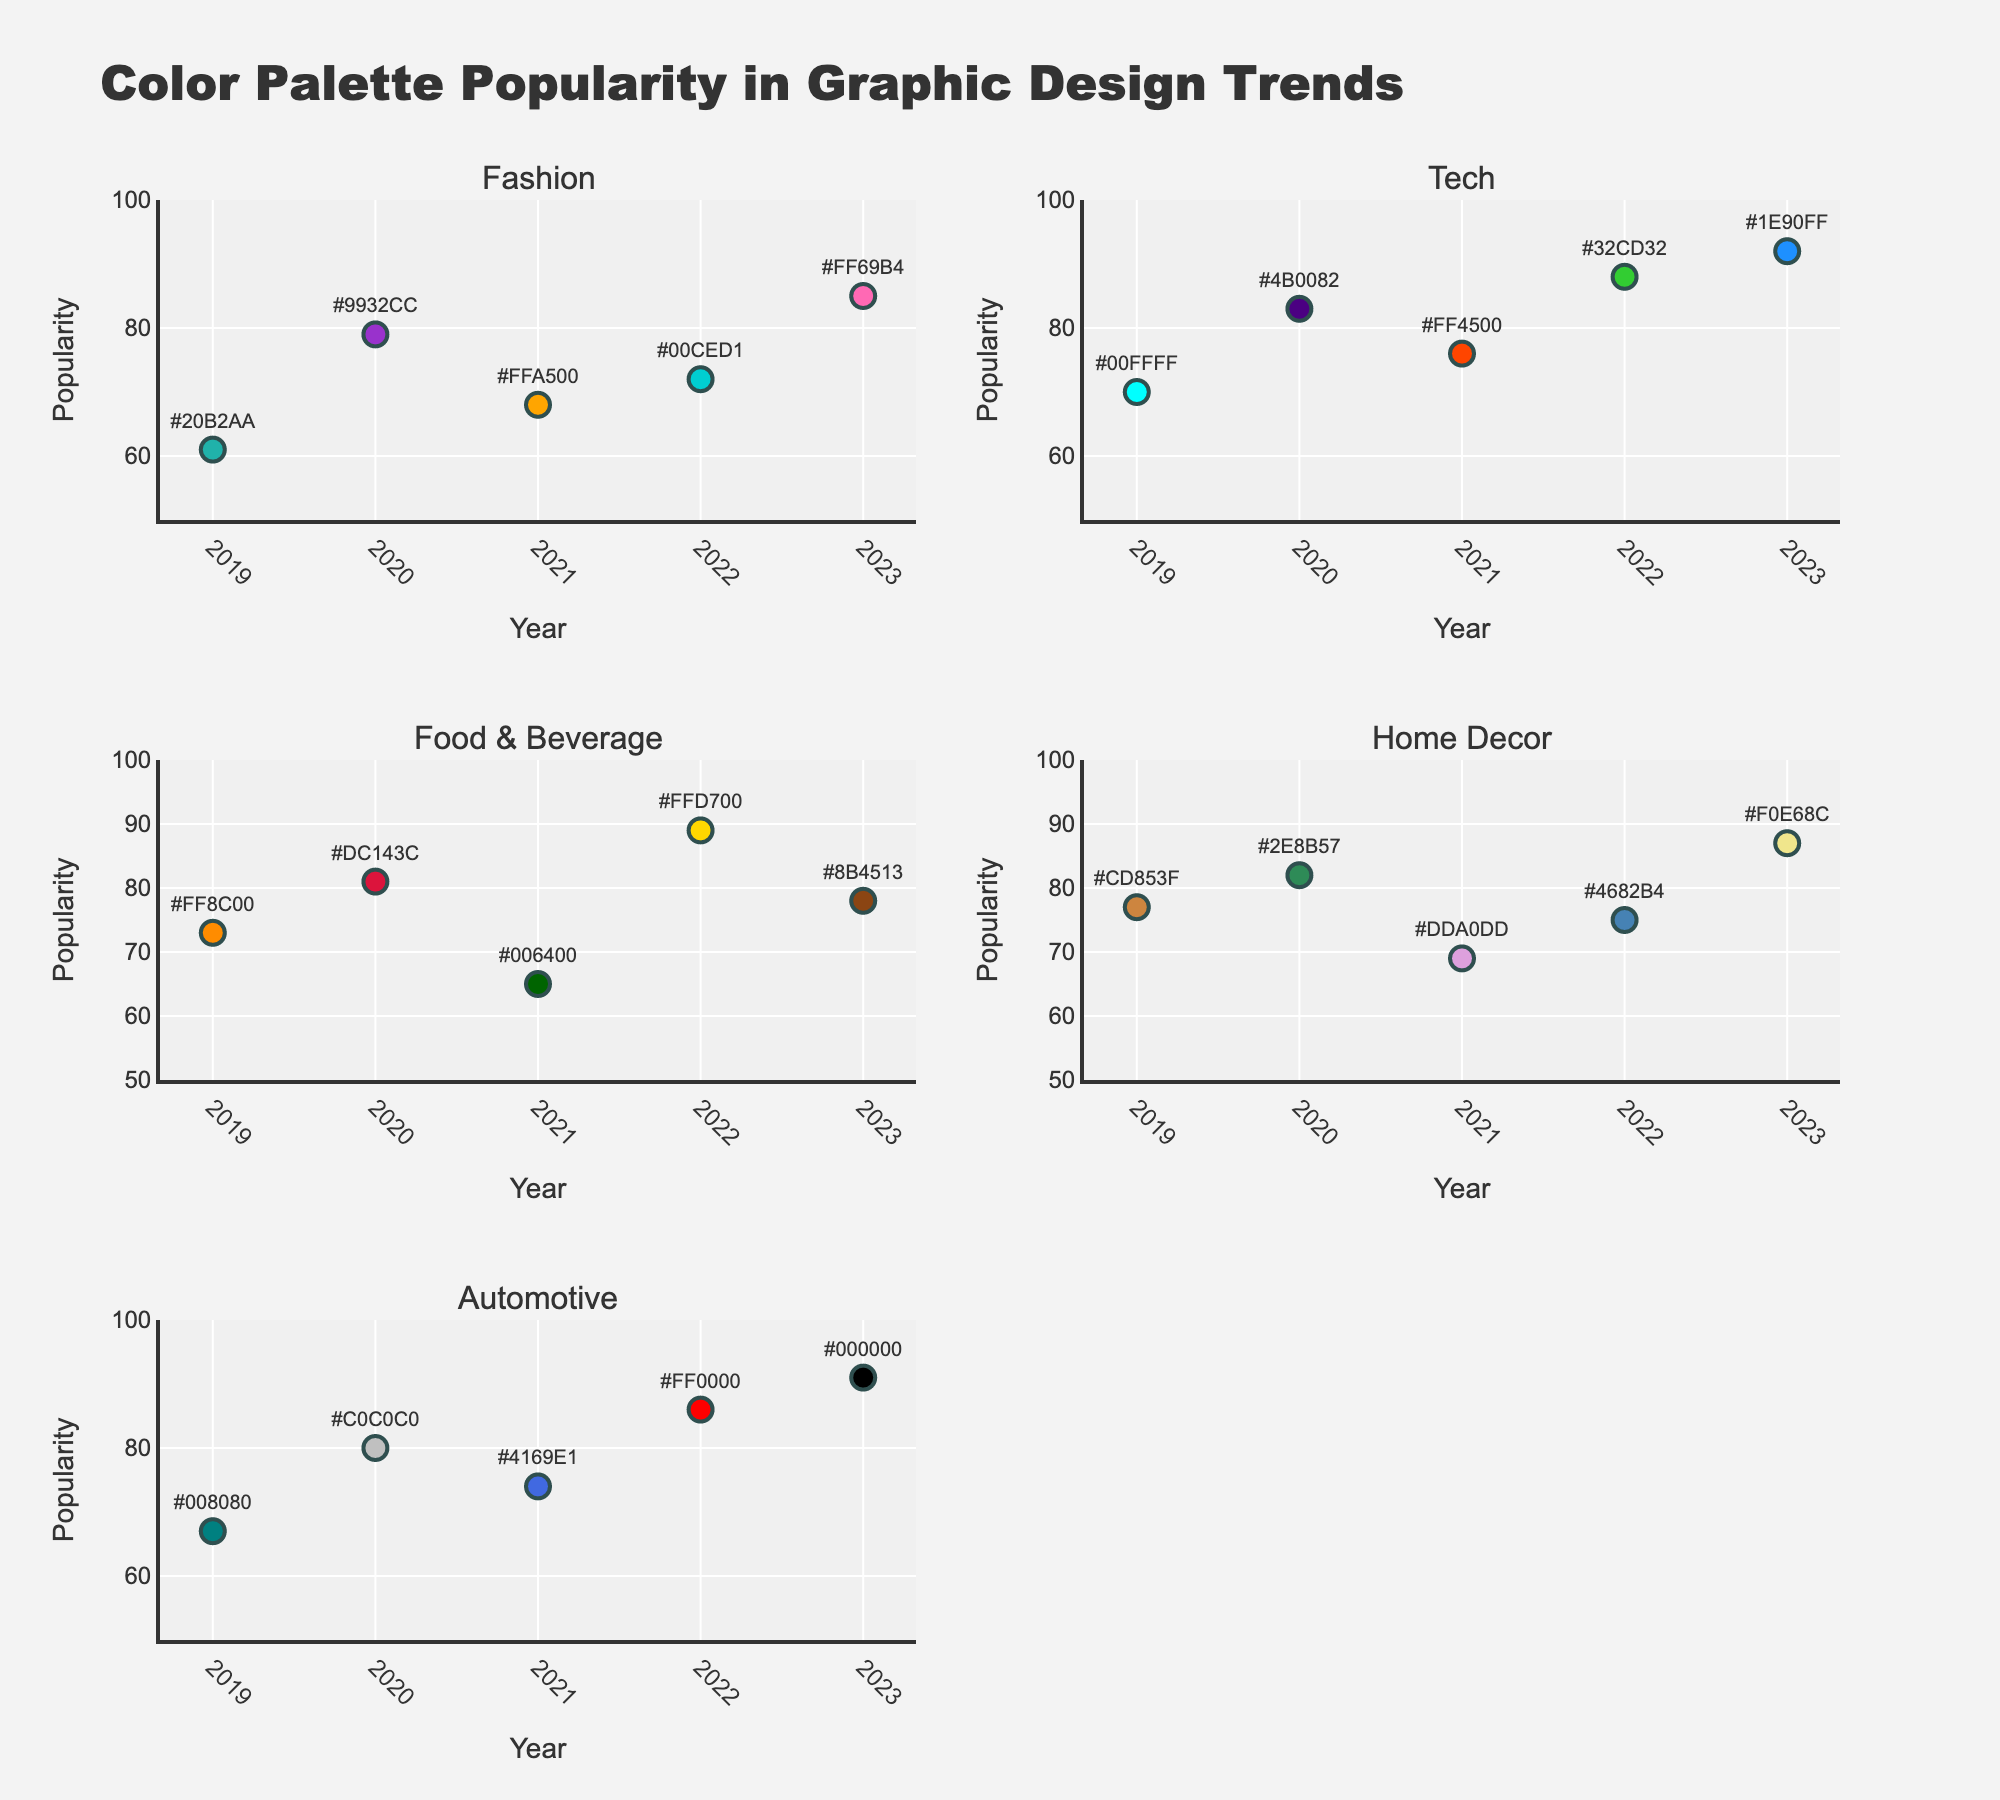What's the title of the figure? The title of the figure is clearly mentioned at the top of the plot.
Answer: Game Genre Analysis What do the x-axes in both subplots represent? The x-axes in both subplots are labeled and represent "Engagement Hours".
Answer: Engagement Hours Which genre has the highest active player count? The bubble chart on the right subplot shows the genre with the largest bubble at the top of the plot indicating the highest active player count. "Puzzle" has the largest bubble and highest position on the y-axis.
Answer: Puzzle What genre has the lowest revenue, and what is its engagement hours? Referring to the left subplot, the lowest point on the y-axis shows the genre with the lowest revenue. The associated x-axis value gives the engagement hours. "Puzzle" is the genre with the lowest revenue at around 50 engagement hours.
Answer: Puzzle, 50 hours Which genre has the highest engagement hours? Looking at both subplots on the x-axis, the right-most bubble indicates the genre with the highest engagement hours. "RPG" has the highest engagement hours at 200 hours.
Answer: RPG How does the active player count for Strategy compare to that for Sports? By observing the right subplot, we identify the positions of "Strategy" and "Sports" and compare their y-axis values (active players). "Sports" has a notably higher position, indicating more active players than "Strategy".
Answer: Sports > Strategy On the left subplot, which genre is portrayed with the largest bubble size? The left subplot's bubble size reflects the active player count, so the largest bubble represents the genre with the most players. "Puzzle" has the largest bubble size.
Answer: Puzzle What is the combined revenue of the genres with the top two engagement hours? Adding the revenues of the genres with the highest engagement hours (RPG and MMO) in the left subplot gives us 550 + 400 = 950 million dollars.
Answer: 950 million dollars Which genre appears to have the highest revenue, and what might be its engagement hours? In the left subplot, the highest point on the y-axis indicates the highest revenue. The corresponding x-axis value provides engagement hours. "Battle Royale" displays the highest revenue at approximately 130 engagement hours.
Answer: Battle Royale, 130 hours Estimate the relationship between engagement hours and active players for MMO and Racing genres. The right subplot shows their comparative positions. "MMO" has higher engagement hours (180 vs. 60) and lower active players compared to "Racing."
Answer: MMO: Higher engagement hours, Lower active players 